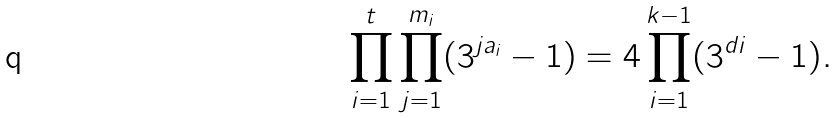<formula> <loc_0><loc_0><loc_500><loc_500>\prod ^ { t } _ { i = 1 } \prod ^ { m _ { i } } _ { j = 1 } ( 3 ^ { j a _ { i } } - 1 ) = 4 \prod ^ { k - 1 } _ { i = 1 } ( 3 ^ { d i } - 1 ) .</formula> 